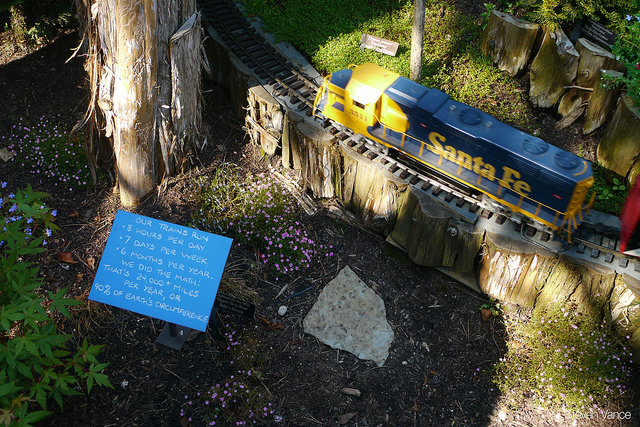<image>Who planted this? It is unknown who planted this. It could be a gardener, landowner, or homeowner. Who planted this? I don't know who planted this. It can be anyone from gardener, landowner, homeowner or no one. 